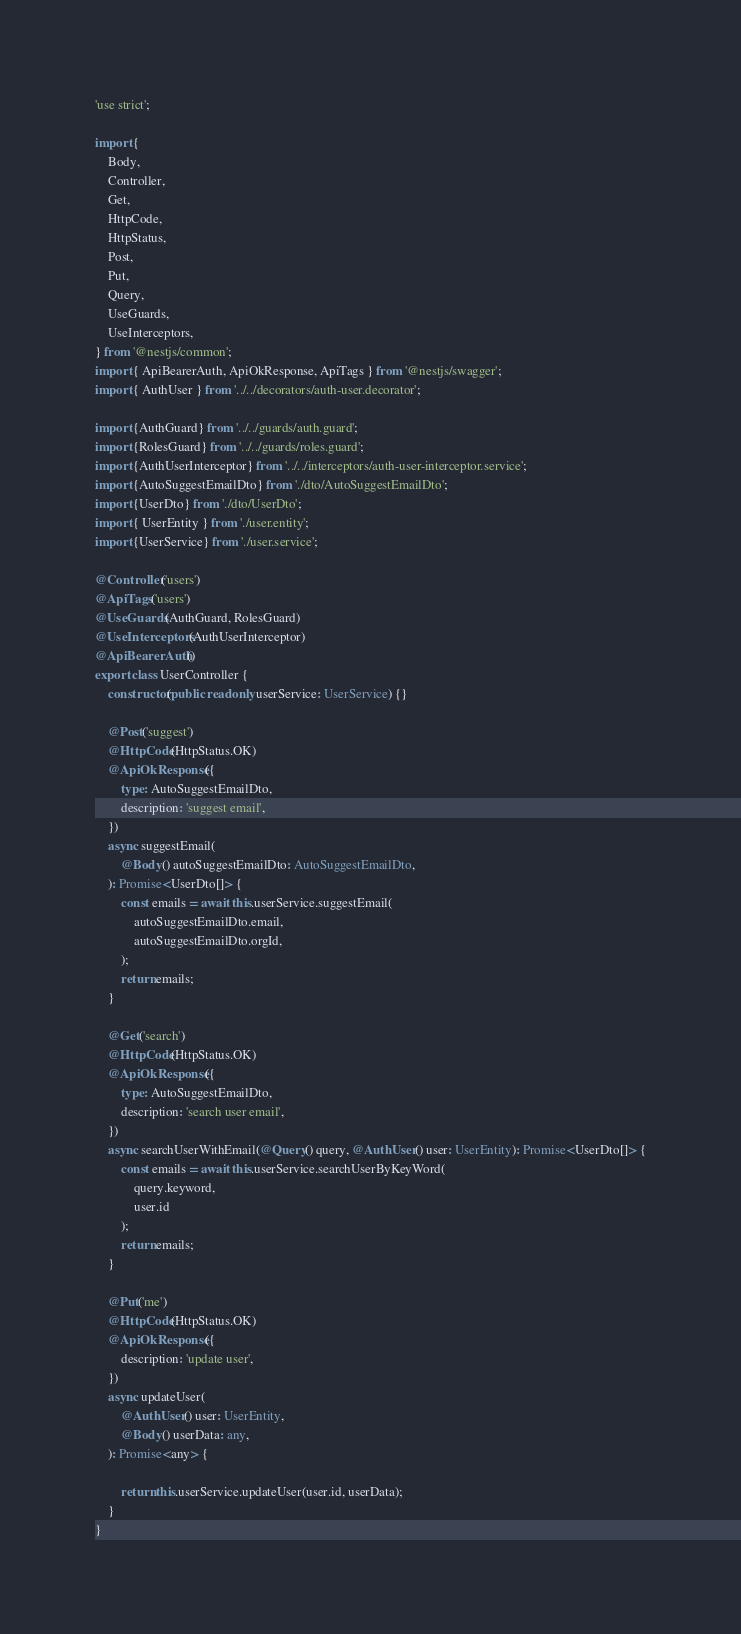Convert code to text. <code><loc_0><loc_0><loc_500><loc_500><_TypeScript_>'use strict';

import {
    Body,
    Controller,
    Get,
    HttpCode,
    HttpStatus,
    Post,
    Put,
    Query,
    UseGuards,
    UseInterceptors,
} from '@nestjs/common';
import { ApiBearerAuth, ApiOkResponse, ApiTags } from '@nestjs/swagger';
import { AuthUser } from '../../decorators/auth-user.decorator';

import {AuthGuard} from '../../guards/auth.guard';
import {RolesGuard} from '../../guards/roles.guard';
import {AuthUserInterceptor} from '../../interceptors/auth-user-interceptor.service';
import {AutoSuggestEmailDto} from './dto/AutoSuggestEmailDto';
import {UserDto} from './dto/UserDto';
import { UserEntity } from './user.entity';
import {UserService} from './user.service';

@Controller('users')
@ApiTags('users')
@UseGuards(AuthGuard, RolesGuard)
@UseInterceptors(AuthUserInterceptor)
@ApiBearerAuth()
export class UserController {
    constructor(public readonly userService: UserService) {}

    @Post('suggest')
    @HttpCode(HttpStatus.OK)
    @ApiOkResponse({
        type: AutoSuggestEmailDto,
        description: 'suggest email',
    })
    async suggestEmail(
        @Body() autoSuggestEmailDto: AutoSuggestEmailDto,
    ): Promise<UserDto[]> {
        const emails = await this.userService.suggestEmail(
            autoSuggestEmailDto.email,
            autoSuggestEmailDto.orgId,
        );
        return emails;
    }

    @Get('search')
    @HttpCode(HttpStatus.OK)
    @ApiOkResponse({
        type: AutoSuggestEmailDto,
        description: 'search user email',
    })
    async searchUserWithEmail(@Query() query, @AuthUser() user: UserEntity): Promise<UserDto[]> {
        const emails = await this.userService.searchUserByKeyWord(
            query.keyword,
            user.id
        );
        return emails;
    }

    @Put('me')
    @HttpCode(HttpStatus.OK)
    @ApiOkResponse({
        description: 'update user',
    })
    async updateUser(
        @AuthUser() user: UserEntity,
        @Body() userData: any,
    ): Promise<any> {

        return this.userService.updateUser(user.id, userData);
    }
}
</code> 